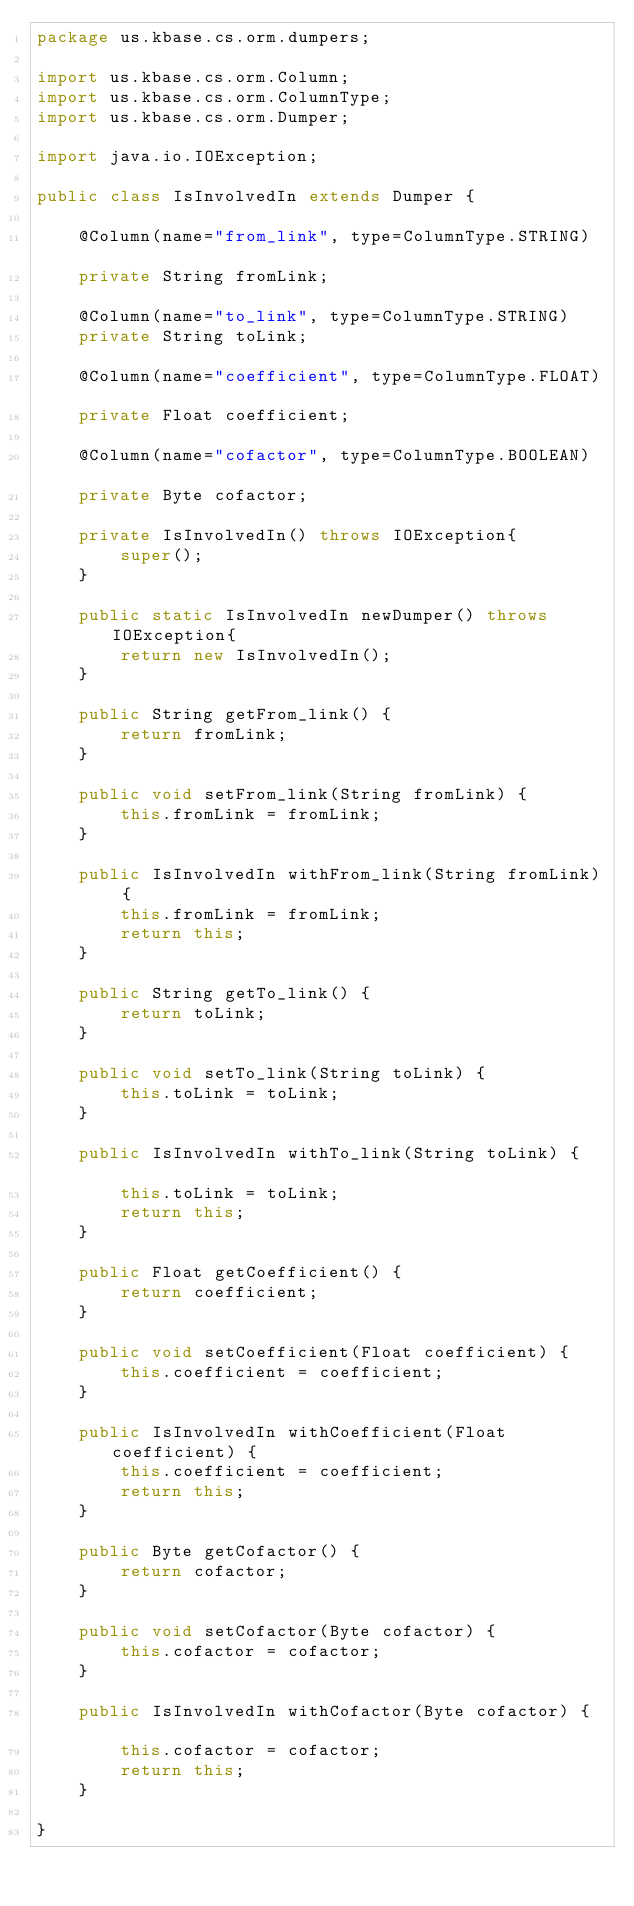<code> <loc_0><loc_0><loc_500><loc_500><_Java_>package us.kbase.cs.orm.dumpers;  	

import us.kbase.cs.orm.Column;
import us.kbase.cs.orm.ColumnType;
import us.kbase.cs.orm.Dumper;

import java.io.IOException;	

public class IsInvolvedIn extends Dumper {  	

    @Column(name="from_link", type=ColumnType.STRING)		
    private String fromLink;									

    @Column(name="to_link", type=ColumnType.STRING)		
    private String toLink;									

    @Column(name="coefficient", type=ColumnType.FLOAT)		
    private Float coefficient;									

    @Column(name="cofactor", type=ColumnType.BOOLEAN)		
    private Byte cofactor;									

    private IsInvolvedIn() throws IOException{		
        super();							
    }										

    public static IsInvolvedIn newDumper() throws IOException{	
        return new IsInvolvedIn();			
    }								

    public String getFrom_link() {		
        return fromLink;				
    }							

    public void setFrom_link(String fromLink) {		
        this.fromLink = fromLink;				
    }								

    public IsInvolvedIn withFrom_link(String fromLink) {				
        this.fromLink = fromLink;						
        return this;						
    }										

    public String getTo_link() {		
        return toLink;				
    }							

    public void setTo_link(String toLink) {		
        this.toLink = toLink;				
    }								

    public IsInvolvedIn withTo_link(String toLink) {				
        this.toLink = toLink;						
        return this;						
    }										

    public Float getCoefficient() {		
        return coefficient;				
    }							

    public void setCoefficient(Float coefficient) {		
        this.coefficient = coefficient;				
    }								

    public IsInvolvedIn withCoefficient(Float coefficient) {				
        this.coefficient = coefficient;						
        return this;						
    }										

    public Byte getCofactor() {		
        return cofactor;				
    }							

    public void setCofactor(Byte cofactor) {		
        this.cofactor = cofactor;				
    }								

    public IsInvolvedIn withCofactor(Byte cofactor) {				
        this.cofactor = cofactor;						
        return this;						
    }										

}
</code> 